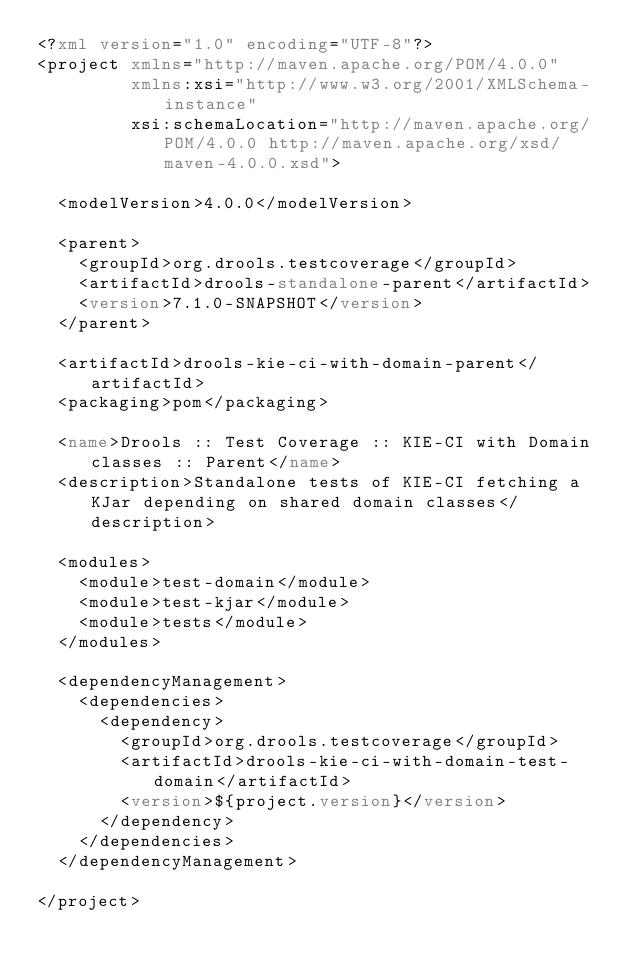Convert code to text. <code><loc_0><loc_0><loc_500><loc_500><_XML_><?xml version="1.0" encoding="UTF-8"?>
<project xmlns="http://maven.apache.org/POM/4.0.0"
         xmlns:xsi="http://www.w3.org/2001/XMLSchema-instance"
         xsi:schemaLocation="http://maven.apache.org/POM/4.0.0 http://maven.apache.org/xsd/maven-4.0.0.xsd">

  <modelVersion>4.0.0</modelVersion>

  <parent>
    <groupId>org.drools.testcoverage</groupId>
    <artifactId>drools-standalone-parent</artifactId>
    <version>7.1.0-SNAPSHOT</version>
  </parent>

  <artifactId>drools-kie-ci-with-domain-parent</artifactId>
  <packaging>pom</packaging>

  <name>Drools :: Test Coverage :: KIE-CI with Domain classes :: Parent</name>
  <description>Standalone tests of KIE-CI fetching a KJar depending on shared domain classes</description>

  <modules>
    <module>test-domain</module>
    <module>test-kjar</module>
    <module>tests</module>
  </modules>

  <dependencyManagement>
    <dependencies>
      <dependency>
        <groupId>org.drools.testcoverage</groupId>
        <artifactId>drools-kie-ci-with-domain-test-domain</artifactId>
        <version>${project.version}</version>
      </dependency>
    </dependencies>
  </dependencyManagement>

</project>
</code> 